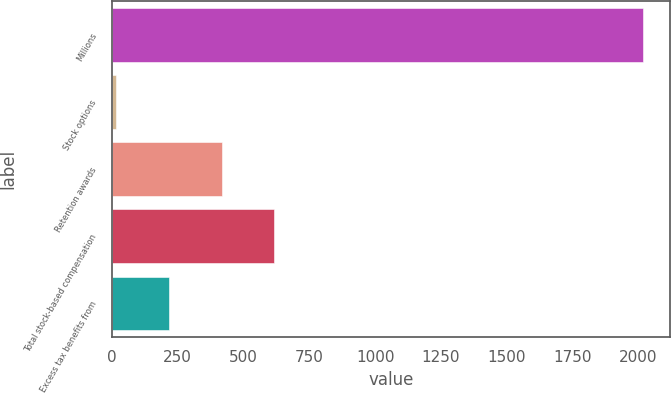<chart> <loc_0><loc_0><loc_500><loc_500><bar_chart><fcel>Millions<fcel>Stock options<fcel>Retention awards<fcel>Total stock-based compensation<fcel>Excess tax benefits from<nl><fcel>2018<fcel>17<fcel>417.2<fcel>617.3<fcel>217.1<nl></chart> 